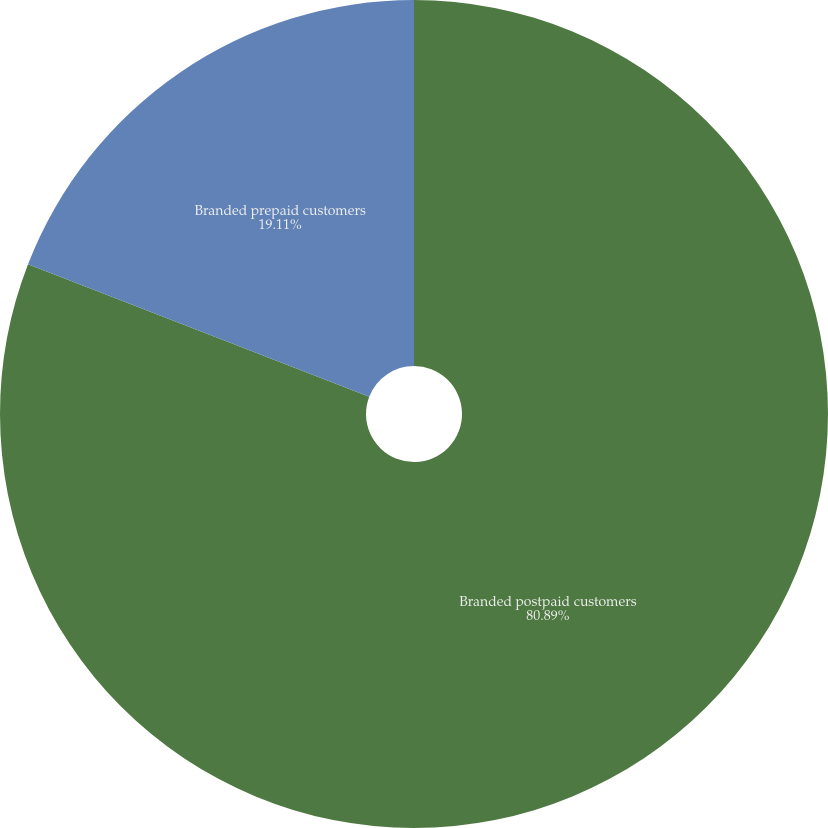<chart> <loc_0><loc_0><loc_500><loc_500><pie_chart><fcel>Branded postpaid customers<fcel>Branded prepaid customers<nl><fcel>80.89%<fcel>19.11%<nl></chart> 